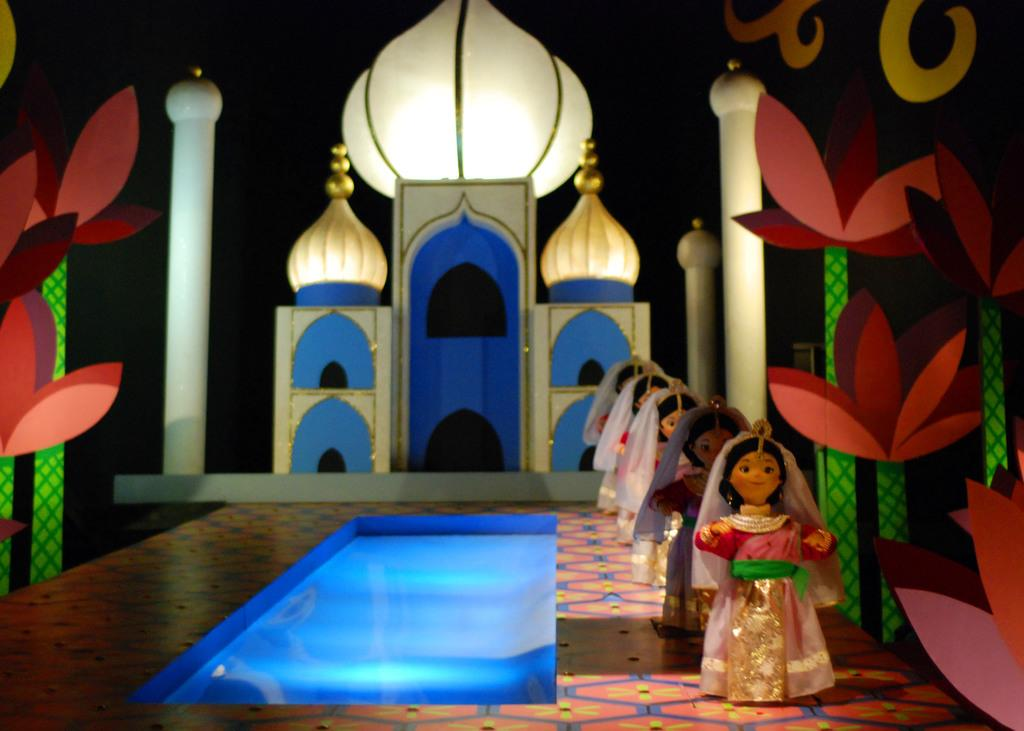What famous landmark is depicted in the image? There is a depiction of the Taj Mahal in the image. What other elements are present in the image besides the Taj Mahal? There are flowers and dolls depicted in the image. What can be seen on the left side of the image? There is water visible on the left side of the image. Are there any pets visible in the image? There are no pets present in the image. Can you tell me how many times the image has been printed? The number of times the image has been printed is not visible or mentioned in the image. 